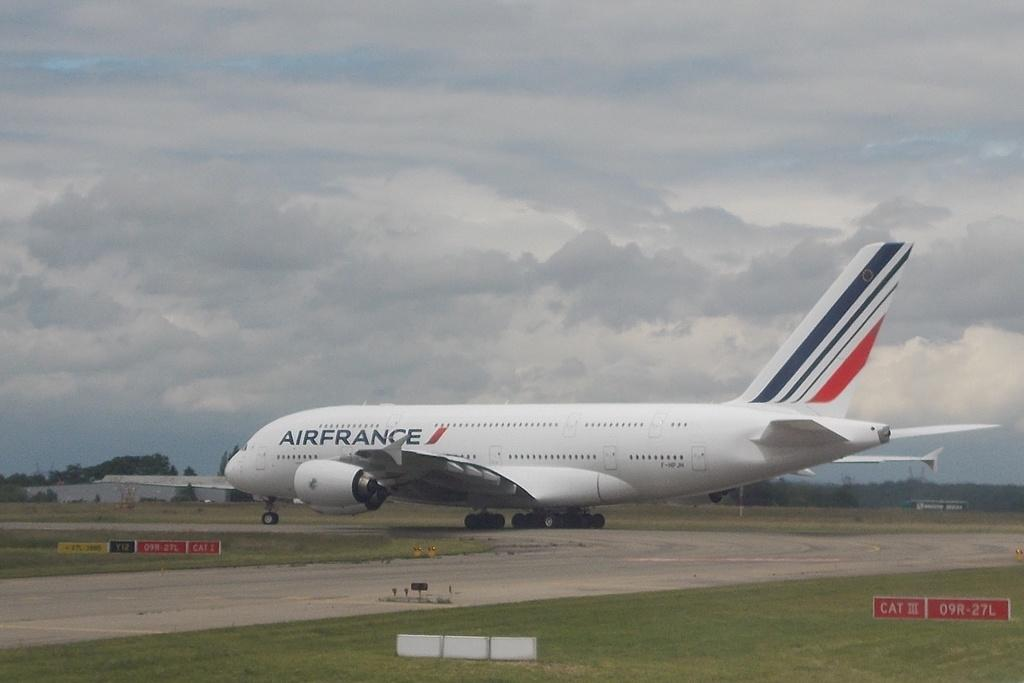<image>
Provide a brief description of the given image. an AIRFRANCE airplane on a landing strip with the landing gear out. 